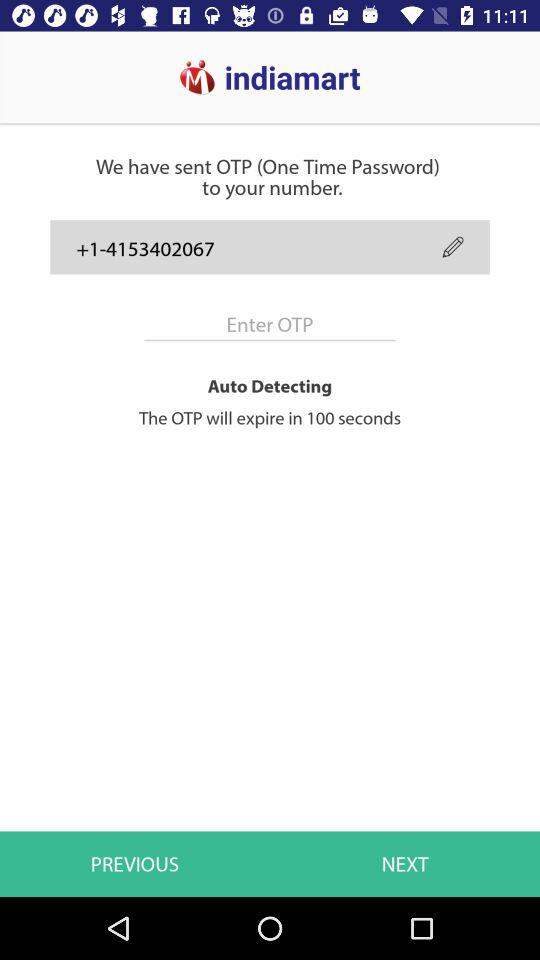What is the contact number? The contact number is +1-4153402067. 